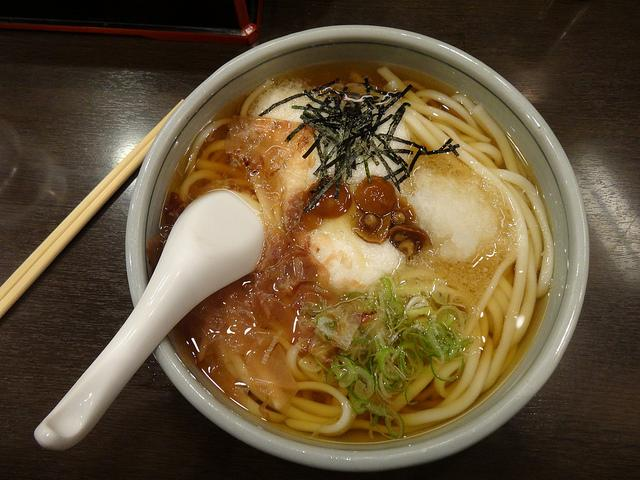What is the bowl made from? glass 